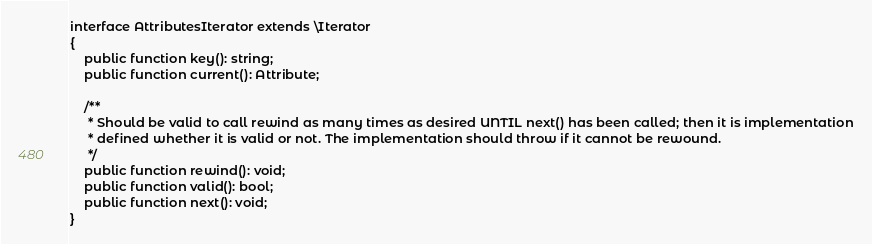<code> <loc_0><loc_0><loc_500><loc_500><_PHP_>interface AttributesIterator extends \Iterator
{
    public function key(): string;
    public function current(): Attribute;

    /**
     * Should be valid to call rewind as many times as desired UNTIL next() has been called; then it is implementation
     * defined whether it is valid or not. The implementation should throw if it cannot be rewound.
     */
    public function rewind(): void;
    public function valid(): bool;
    public function next(): void;
}
</code> 